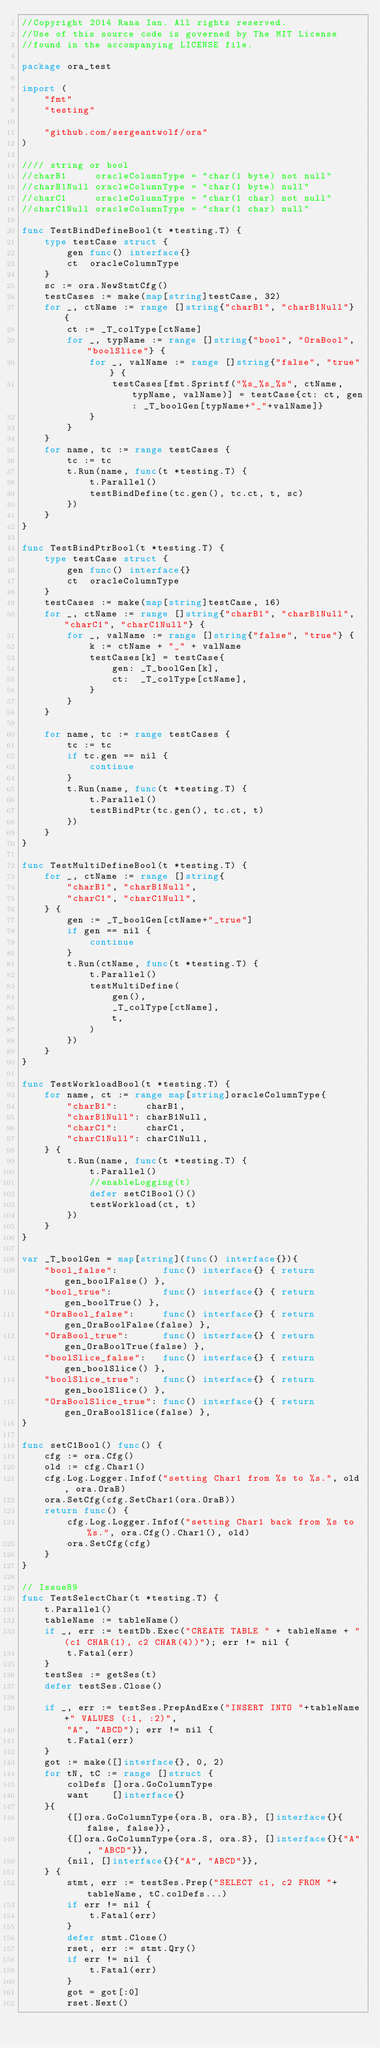<code> <loc_0><loc_0><loc_500><loc_500><_Go_>//Copyright 2014 Rana Ian. All rights reserved.
//Use of this source code is governed by The MIT License
//found in the accompanying LICENSE file.

package ora_test

import (
	"fmt"
	"testing"

	"github.com/sergeantwolf/ora"
)

//// string or bool
//charB1     oracleColumnType = "char(1 byte) not null"
//charB1Null oracleColumnType = "char(1 byte) null"
//charC1     oracleColumnType = "char(1 char) not null"
//charC1Null oracleColumnType = "char(1 char) null"

func TestBindDefineBool(t *testing.T) {
	type testCase struct {
		gen func() interface{}
		ct  oracleColumnType
	}
	sc := ora.NewStmtCfg()
	testCases := make(map[string]testCase, 32)
	for _, ctName := range []string{"charB1", "charB1Null"} {
		ct := _T_colType[ctName]
		for _, typName := range []string{"bool", "OraBool", "boolSlice"} {
			for _, valName := range []string{"false", "true"} {
				testCases[fmt.Sprintf("%s_%s_%s", ctName, typName, valName)] = testCase{ct: ct, gen: _T_boolGen[typName+"_"+valName]}
			}
		}
	}
	for name, tc := range testCases {
		tc := tc
		t.Run(name, func(t *testing.T) {
			t.Parallel()
			testBindDefine(tc.gen(), tc.ct, t, sc)
		})
	}
}

func TestBindPtrBool(t *testing.T) {
	type testCase struct {
		gen func() interface{}
		ct  oracleColumnType
	}
	testCases := make(map[string]testCase, 16)
	for _, ctName := range []string{"charB1", "charB1Null", "charC1", "charC1Null"} {
		for _, valName := range []string{"false", "true"} {
			k := ctName + "_" + valName
			testCases[k] = testCase{
				gen: _T_boolGen[k],
				ct:  _T_colType[ctName],
			}
		}
	}

	for name, tc := range testCases {
		tc := tc
		if tc.gen == nil {
			continue
		}
		t.Run(name, func(t *testing.T) {
			t.Parallel()
			testBindPtr(tc.gen(), tc.ct, t)
		})
	}
}

func TestMultiDefineBool(t *testing.T) {
	for _, ctName := range []string{
		"charB1", "charB1Null",
		"charC1", "charC1Null",
	} {
		gen := _T_boolGen[ctName+"_true"]
		if gen == nil {
			continue
		}
		t.Run(ctName, func(t *testing.T) {
			t.Parallel()
			testMultiDefine(
				gen(),
				_T_colType[ctName],
				t,
			)
		})
	}
}

func TestWorkloadBool(t *testing.T) {
	for name, ct := range map[string]oracleColumnType{
		"charB1":     charB1,
		"charB1Null": charB1Null,
		"charC1":     charC1,
		"charC1Null": charC1Null,
	} {
		t.Run(name, func(t *testing.T) {
			t.Parallel()
			//enableLogging(t)
			defer setC1Bool()()
			testWorkload(ct, t)
		})
	}
}

var _T_boolGen = map[string](func() interface{}){
	"bool_false":        func() interface{} { return gen_boolFalse() },
	"bool_true":         func() interface{} { return gen_boolTrue() },
	"OraBool_false":     func() interface{} { return gen_OraBoolFalse(false) },
	"OraBool_true":      func() interface{} { return gen_OraBoolTrue(false) },
	"boolSlice_false":   func() interface{} { return gen_boolSlice() },
	"boolSlice_true":    func() interface{} { return gen_boolSlice() },
	"OraBoolSlice_true": func() interface{} { return gen_OraBoolSlice(false) },
}

func setC1Bool() func() {
	cfg := ora.Cfg()
	old := cfg.Char1()
	cfg.Log.Logger.Infof("setting Char1 from %s to %s.", old, ora.OraB)
	ora.SetCfg(cfg.SetChar1(ora.OraB))
	return func() {
		cfg.Log.Logger.Infof("setting Char1 back from %s to %s.", ora.Cfg().Char1(), old)
		ora.SetCfg(cfg)
	}
}

// Issue89
func TestSelectChar(t *testing.T) {
	t.Parallel()
	tableName := tableName()
	if _, err := testDb.Exec("CREATE TABLE " + tableName + "(c1 CHAR(1), c2 CHAR(4))"); err != nil {
		t.Fatal(err)
	}
	testSes := getSes(t)
	defer testSes.Close()

	if _, err := testSes.PrepAndExe("INSERT INTO "+tableName+" VALUES (:1, :2)",
		"A", "ABCD"); err != nil {
		t.Fatal(err)
	}
	got := make([]interface{}, 0, 2)
	for tN, tC := range []struct {
		colDefs []ora.GoColumnType
		want    []interface{}
	}{
		{[]ora.GoColumnType{ora.B, ora.B}, []interface{}{false, false}},
		{[]ora.GoColumnType{ora.S, ora.S}, []interface{}{"A", "ABCD"}},
		{nil, []interface{}{"A", "ABCD"}},
	} {
		stmt, err := testSes.Prep("SELECT c1, c2 FROM "+tableName, tC.colDefs...)
		if err != nil {
			t.Fatal(err)
		}
		defer stmt.Close()
		rset, err := stmt.Qry()
		if err != nil {
			t.Fatal(err)
		}
		got = got[:0]
		rset.Next()</code> 